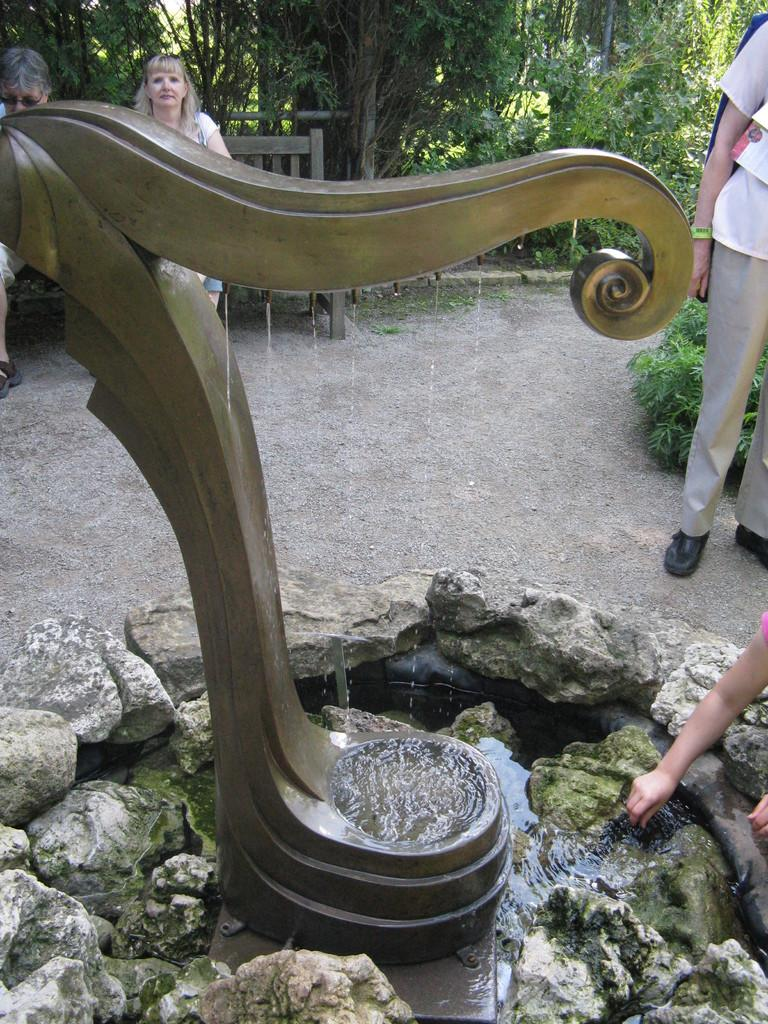What is the main feature in the image? There is a fountain in the image. What surrounds the fountain? Rocks are present around the fountain. Can you describe the people in the background? There are two persons sitting on a bench in the background. What type of vegetation is visible in the image? Trees are visible in the image. Where is the person standing in the image? There is a person standing on the right side of the image. How many brothers can be seen in the image? There is no mention of brothers in the image; it features a fountain, rocks, trees, and people. What is the color of the moon in the image? There is no moon present in the image. 